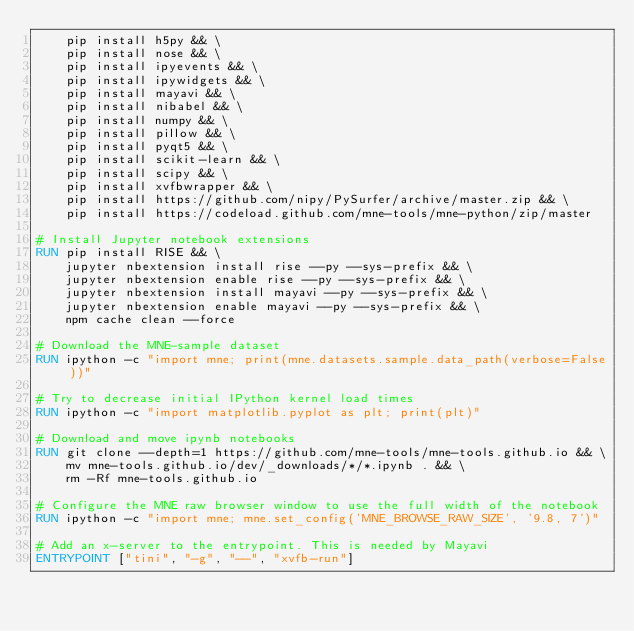Convert code to text. <code><loc_0><loc_0><loc_500><loc_500><_Dockerfile_>    pip install h5py && \
    pip install nose && \
    pip install ipyevents && \
    pip install ipywidgets && \
    pip install mayavi && \
    pip install nibabel && \
    pip install numpy && \
    pip install pillow && \
    pip install pyqt5 && \
    pip install scikit-learn && \
    pip install scipy && \
    pip install xvfbwrapper && \
    pip install https://github.com/nipy/PySurfer/archive/master.zip && \
    pip install https://codeload.github.com/mne-tools/mne-python/zip/master

# Install Jupyter notebook extensions
RUN pip install RISE && \
    jupyter nbextension install rise --py --sys-prefix && \
    jupyter nbextension enable rise --py --sys-prefix && \
    jupyter nbextension install mayavi --py --sys-prefix && \
    jupyter nbextension enable mayavi --py --sys-prefix && \
    npm cache clean --force

# Download the MNE-sample dataset
RUN ipython -c "import mne; print(mne.datasets.sample.data_path(verbose=False))"

# Try to decrease initial IPython kernel load times
RUN ipython -c "import matplotlib.pyplot as plt; print(plt)"

# Download and move ipynb notebooks
RUN git clone --depth=1 https://github.com/mne-tools/mne-tools.github.io && \
    mv mne-tools.github.io/dev/_downloads/*/*.ipynb . && \
    rm -Rf mne-tools.github.io

# Configure the MNE raw browser window to use the full width of the notebook
RUN ipython -c "import mne; mne.set_config('MNE_BROWSE_RAW_SIZE', '9.8, 7')"

# Add an x-server to the entrypoint. This is needed by Mayavi
ENTRYPOINT ["tini", "-g", "--", "xvfb-run"]
</code> 